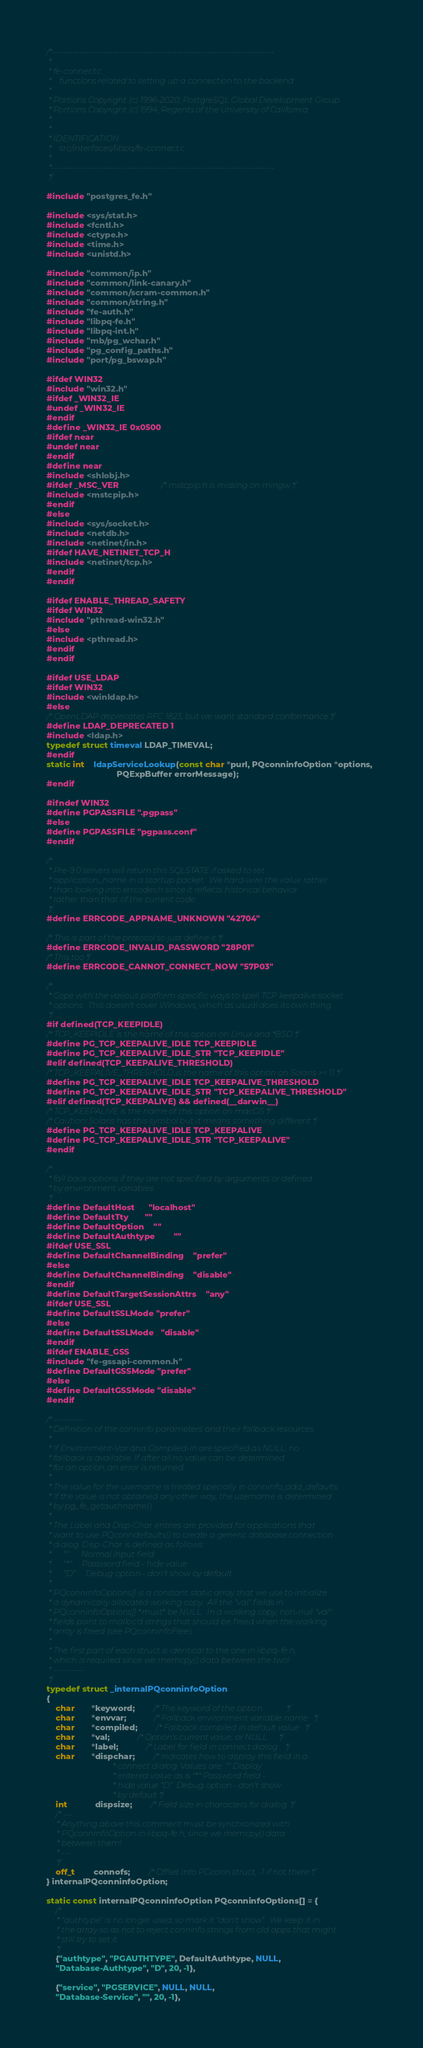<code> <loc_0><loc_0><loc_500><loc_500><_C_>/*-------------------------------------------------------------------------
 *
 * fe-connect.c
 *	  functions related to setting up a connection to the backend
 *
 * Portions Copyright (c) 1996-2020, PostgreSQL Global Development Group
 * Portions Copyright (c) 1994, Regents of the University of California
 *
 *
 * IDENTIFICATION
 *	  src/interfaces/libpq/fe-connect.c
 *
 *-------------------------------------------------------------------------
 */

#include "postgres_fe.h"

#include <sys/stat.h>
#include <fcntl.h>
#include <ctype.h>
#include <time.h>
#include <unistd.h>

#include "common/ip.h"
#include "common/link-canary.h"
#include "common/scram-common.h"
#include "common/string.h"
#include "fe-auth.h"
#include "libpq-fe.h"
#include "libpq-int.h"
#include "mb/pg_wchar.h"
#include "pg_config_paths.h"
#include "port/pg_bswap.h"

#ifdef WIN32
#include "win32.h"
#ifdef _WIN32_IE
#undef _WIN32_IE
#endif
#define _WIN32_IE 0x0500
#ifdef near
#undef near
#endif
#define near
#include <shlobj.h>
#ifdef _MSC_VER					/* mstcpip.h is missing on mingw */
#include <mstcpip.h>
#endif
#else
#include <sys/socket.h>
#include <netdb.h>
#include <netinet/in.h>
#ifdef HAVE_NETINET_TCP_H
#include <netinet/tcp.h>
#endif
#endif

#ifdef ENABLE_THREAD_SAFETY
#ifdef WIN32
#include "pthread-win32.h"
#else
#include <pthread.h>
#endif
#endif

#ifdef USE_LDAP
#ifdef WIN32
#include <winldap.h>
#else
/* OpenLDAP deprecates RFC 1823, but we want standard conformance */
#define LDAP_DEPRECATED 1
#include <ldap.h>
typedef struct timeval LDAP_TIMEVAL;
#endif
static int	ldapServiceLookup(const char *purl, PQconninfoOption *options,
							  PQExpBuffer errorMessage);
#endif

#ifndef WIN32
#define PGPASSFILE ".pgpass"
#else
#define PGPASSFILE "pgpass.conf"
#endif

/*
 * Pre-9.0 servers will return this SQLSTATE if asked to set
 * application_name in a startup packet.  We hard-wire the value rather
 * than looking into errcodes.h since it reflects historical behavior
 * rather than that of the current code.
 */
#define ERRCODE_APPNAME_UNKNOWN "42704"

/* This is part of the protocol so just define it */
#define ERRCODE_INVALID_PASSWORD "28P01"
/* This too */
#define ERRCODE_CANNOT_CONNECT_NOW "57P03"

/*
 * Cope with the various platform-specific ways to spell TCP keepalive socket
 * options.  This doesn't cover Windows, which as usual does its own thing.
 */
#if defined(TCP_KEEPIDLE)
/* TCP_KEEPIDLE is the name of this option on Linux and *BSD */
#define PG_TCP_KEEPALIVE_IDLE TCP_KEEPIDLE
#define PG_TCP_KEEPALIVE_IDLE_STR "TCP_KEEPIDLE"
#elif defined(TCP_KEEPALIVE_THRESHOLD)
/* TCP_KEEPALIVE_THRESHOLD is the name of this option on Solaris >= 11 */
#define PG_TCP_KEEPALIVE_IDLE TCP_KEEPALIVE_THRESHOLD
#define PG_TCP_KEEPALIVE_IDLE_STR "TCP_KEEPALIVE_THRESHOLD"
#elif defined(TCP_KEEPALIVE) && defined(__darwin__)
/* TCP_KEEPALIVE is the name of this option on macOS */
/* Caution: Solaris has this symbol but it means something different */
#define PG_TCP_KEEPALIVE_IDLE TCP_KEEPALIVE
#define PG_TCP_KEEPALIVE_IDLE_STR "TCP_KEEPALIVE"
#endif

/*
 * fall back options if they are not specified by arguments or defined
 * by environment variables
 */
#define DefaultHost		"localhost"
#define DefaultTty		""
#define DefaultOption	""
#define DefaultAuthtype		  ""
#ifdef USE_SSL
#define DefaultChannelBinding	"prefer"
#else
#define DefaultChannelBinding	"disable"
#endif
#define DefaultTargetSessionAttrs	"any"
#ifdef USE_SSL
#define DefaultSSLMode "prefer"
#else
#define DefaultSSLMode	"disable"
#endif
#ifdef ENABLE_GSS
#include "fe-gssapi-common.h"
#define DefaultGSSMode "prefer"
#else
#define DefaultGSSMode "disable"
#endif

/* ----------
 * Definition of the conninfo parameters and their fallback resources.
 *
 * If Environment-Var and Compiled-in are specified as NULL, no
 * fallback is available. If after all no value can be determined
 * for an option, an error is returned.
 *
 * The value for the username is treated specially in conninfo_add_defaults.
 * If the value is not obtained any other way, the username is determined
 * by pg_fe_getauthname().
 *
 * The Label and Disp-Char entries are provided for applications that
 * want to use PQconndefaults() to create a generic database connection
 * dialog. Disp-Char is defined as follows:
 *		""		Normal input field
 *		"*"		Password field - hide value
 *		"D"		Debug option - don't show by default
 *
 * PQconninfoOptions[] is a constant static array that we use to initialize
 * a dynamically allocated working copy.  All the "val" fields in
 * PQconninfoOptions[] *must* be NULL.  In a working copy, non-null "val"
 * fields point to malloc'd strings that should be freed when the working
 * array is freed (see PQconninfoFree).
 *
 * The first part of each struct is identical to the one in libpq-fe.h,
 * which is required since we memcpy() data between the two!
 * ----------
 */
typedef struct _internalPQconninfoOption
{
	char	   *keyword;		/* The keyword of the option			*/
	char	   *envvar;			/* Fallback environment variable name	*/
	char	   *compiled;		/* Fallback compiled in default value	*/
	char	   *val;			/* Option's current value, or NULL		*/
	char	   *label;			/* Label for field in connect dialog	*/
	char	   *dispchar;		/* Indicates how to display this field in a
								 * connect dialog. Values are: "" Display
								 * entered value as is "*" Password field -
								 * hide value "D"  Debug option - don't show
								 * by default */
	int			dispsize;		/* Field size in characters for dialog	*/
	/* ---
	 * Anything above this comment must be synchronized with
	 * PQconninfoOption in libpq-fe.h, since we memcpy() data
	 * between them!
	 * ---
	 */
	off_t		connofs;		/* Offset into PGconn struct, -1 if not there */
} internalPQconninfoOption;

static const internalPQconninfoOption PQconninfoOptions[] = {
	/*
	 * "authtype" is no longer used, so mark it "don't show".  We keep it in
	 * the array so as not to reject conninfo strings from old apps that might
	 * still try to set it.
	 */
	{"authtype", "PGAUTHTYPE", DefaultAuthtype, NULL,
	"Database-Authtype", "D", 20, -1},

	{"service", "PGSERVICE", NULL, NULL,
	"Database-Service", "", 20, -1},
</code> 